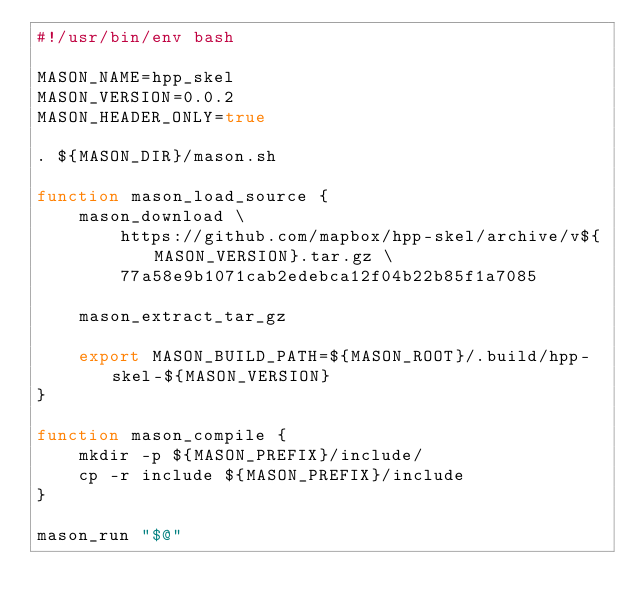Convert code to text. <code><loc_0><loc_0><loc_500><loc_500><_Bash_>#!/usr/bin/env bash

MASON_NAME=hpp_skel
MASON_VERSION=0.0.2
MASON_HEADER_ONLY=true

. ${MASON_DIR}/mason.sh

function mason_load_source {
    mason_download \
        https://github.com/mapbox/hpp-skel/archive/v${MASON_VERSION}.tar.gz \
        77a58e9b1071cab2edebca12f04b22b85f1a7085

    mason_extract_tar_gz

    export MASON_BUILD_PATH=${MASON_ROOT}/.build/hpp-skel-${MASON_VERSION}
}

function mason_compile {
    mkdir -p ${MASON_PREFIX}/include/
    cp -r include ${MASON_PREFIX}/include
}

mason_run "$@"</code> 